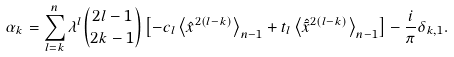Convert formula to latex. <formula><loc_0><loc_0><loc_500><loc_500>\alpha _ { k } = \sum _ { l = k } ^ { n } \lambda ^ { l } { { 2 l - 1 } \choose { 2 k - 1 } } \left [ - c _ { l } \left \langle \hat { x } ^ { 2 ( l - k ) } \right \rangle _ { n - 1 } + t _ { l } \left \langle \hat { \tilde { x } } ^ { 2 ( l - k ) } \right \rangle _ { n - 1 } \right ] - \frac { i } { \pi } \delta _ { k , 1 } .</formula> 